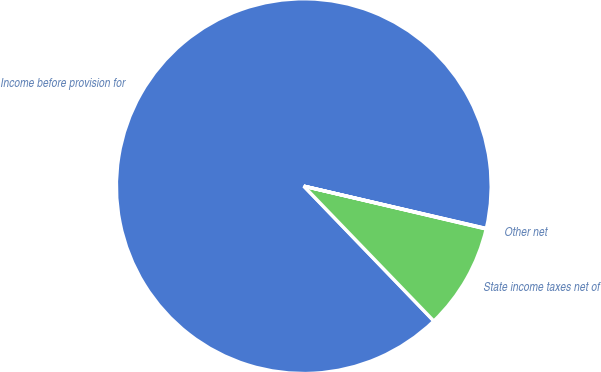Convert chart. <chart><loc_0><loc_0><loc_500><loc_500><pie_chart><fcel>Income before provision for<fcel>State income taxes net of<fcel>Other net<nl><fcel>90.83%<fcel>9.12%<fcel>0.04%<nl></chart> 